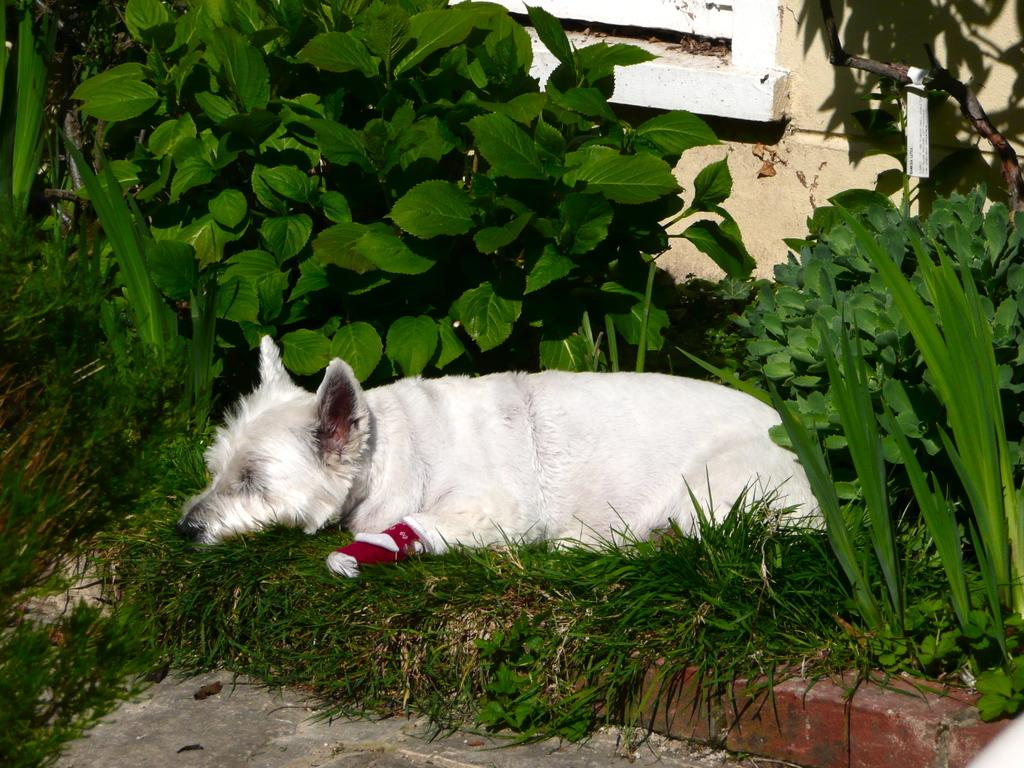Where was the picture taken? The picture was taken outside. What type of animal can be seen in the image? There is a white color dog in the image. What is the dog doing in the image? The dog appears to be sleeping on the grass. What can be seen growing in the image? There are plants visible in the image. What is visible in the background of the image? There is a wall in the background of the image. What is the chance of the tramp winning the race in the image? There is no tramp or race present in the image; it features a dog sleeping on the grass. 